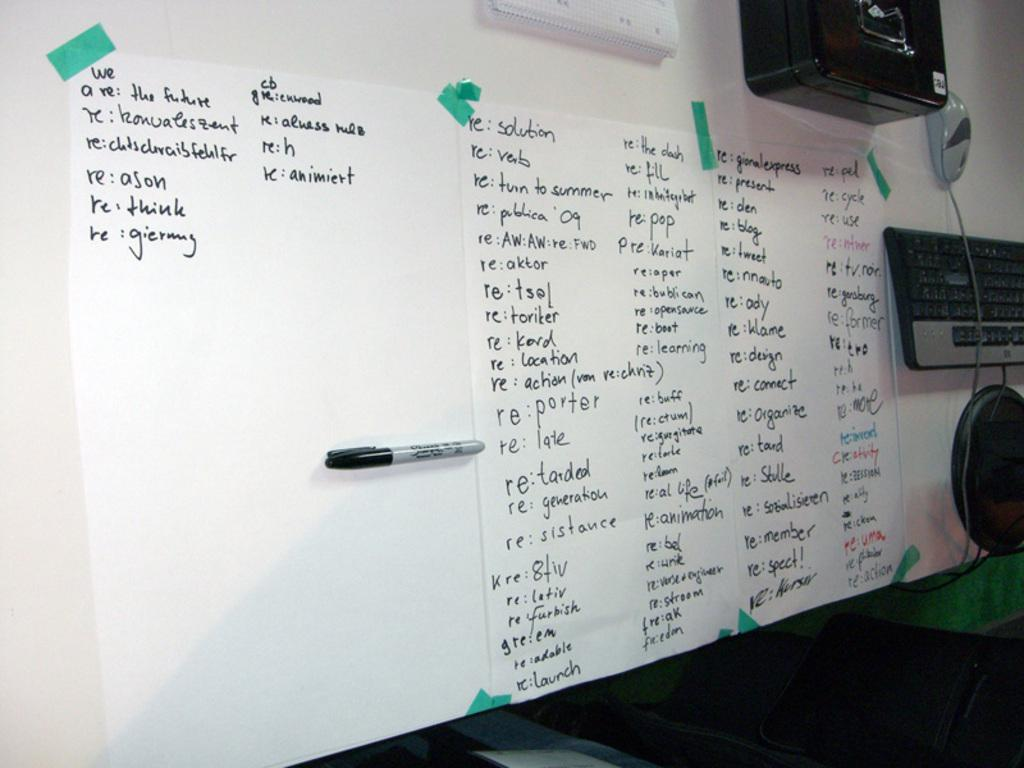<image>
Write a terse but informative summary of the picture. Three large sheets of paper with words begining with RE are taped to a table. 